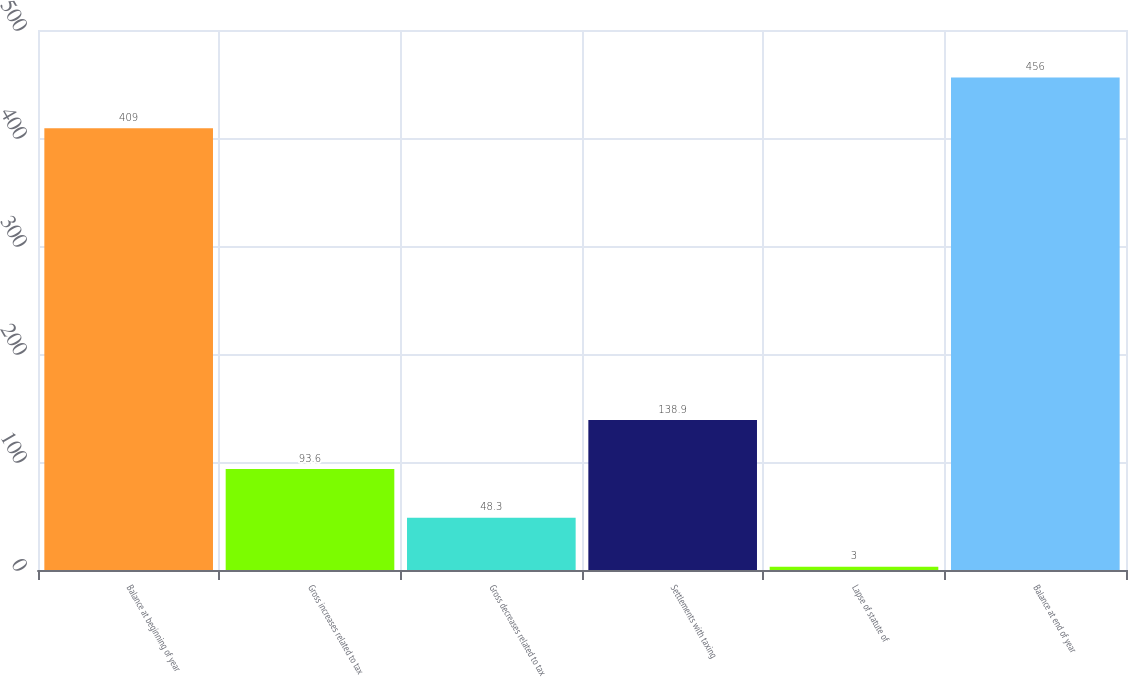Convert chart to OTSL. <chart><loc_0><loc_0><loc_500><loc_500><bar_chart><fcel>Balance at beginning of year<fcel>Gross increases related to tax<fcel>Gross decreases related to tax<fcel>Settlements with taxing<fcel>Lapse of statute of<fcel>Balance at end of year<nl><fcel>409<fcel>93.6<fcel>48.3<fcel>138.9<fcel>3<fcel>456<nl></chart> 